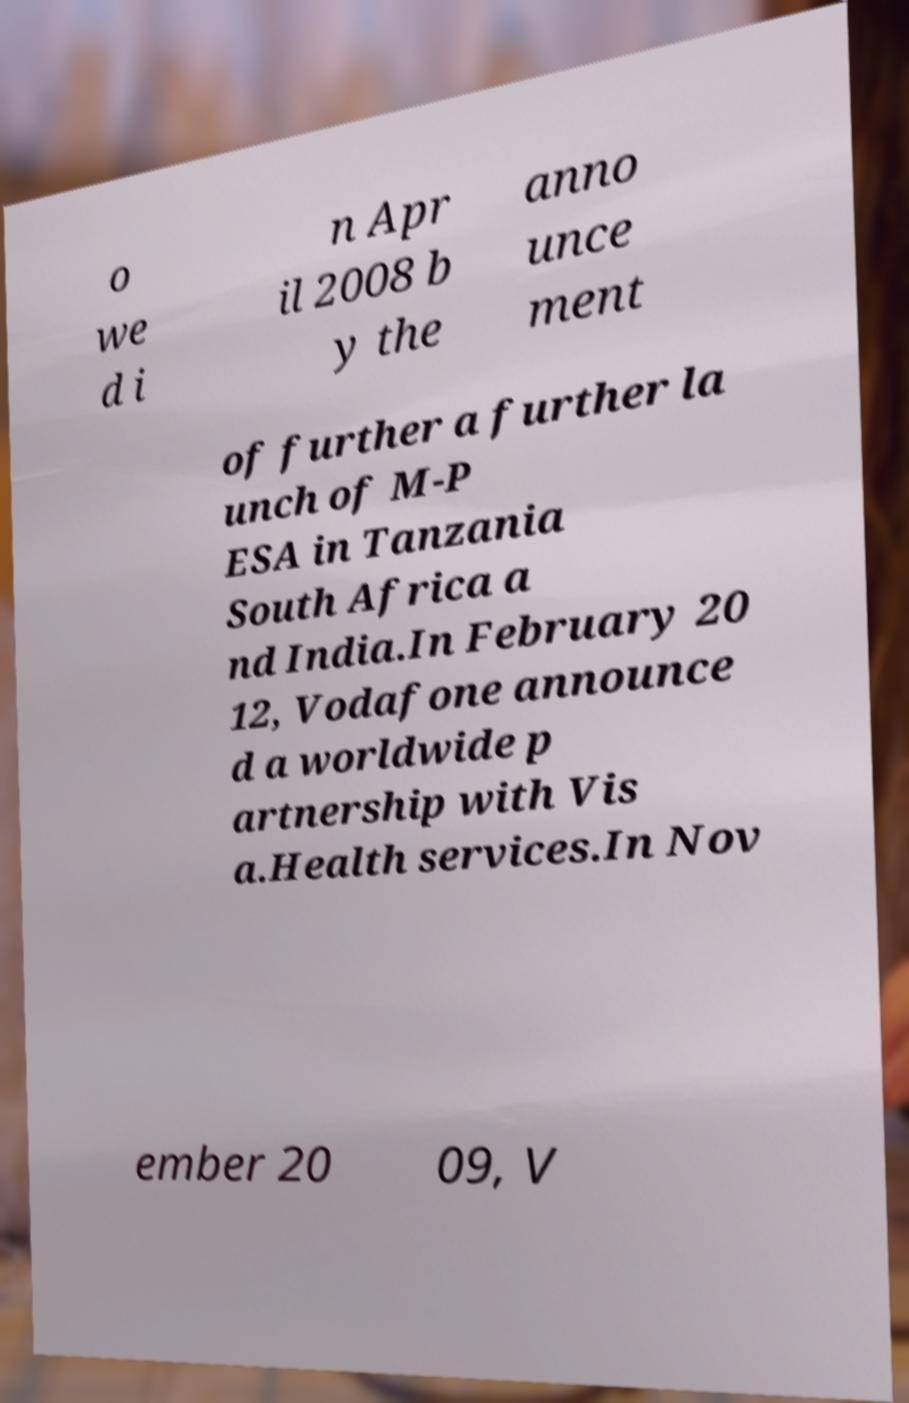Please read and relay the text visible in this image. What does it say? o we d i n Apr il 2008 b y the anno unce ment of further a further la unch of M-P ESA in Tanzania South Africa a nd India.In February 20 12, Vodafone announce d a worldwide p artnership with Vis a.Health services.In Nov ember 20 09, V 